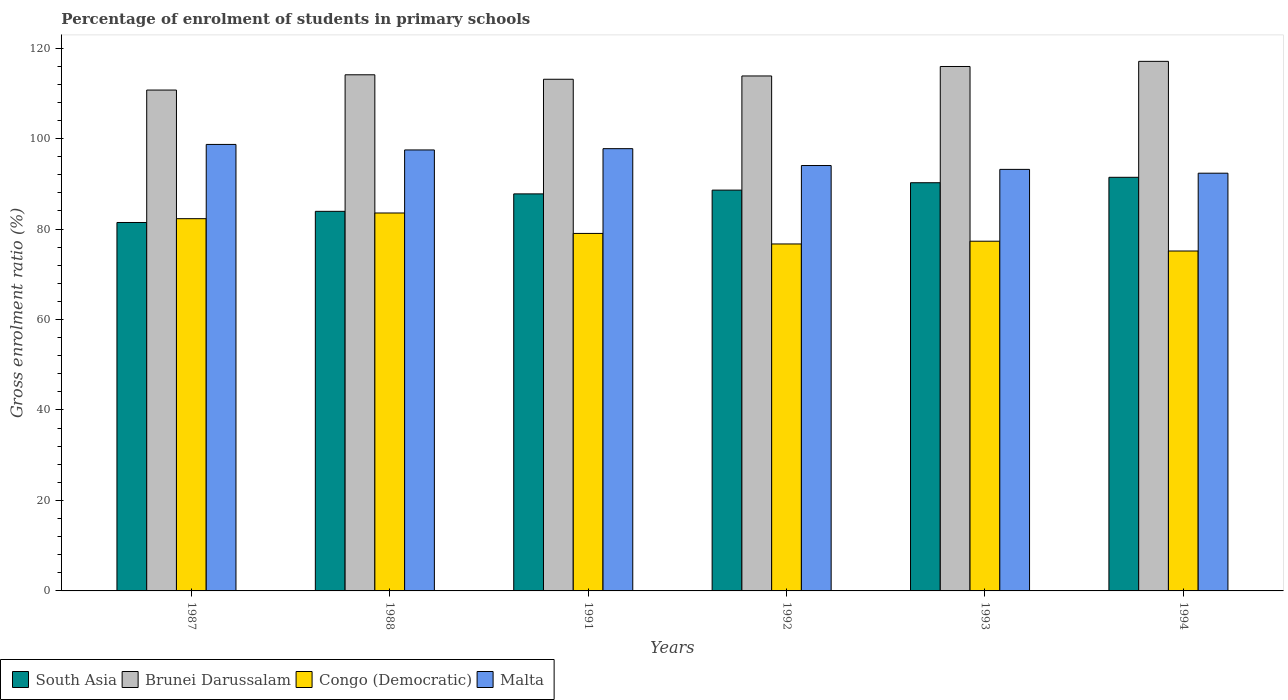Are the number of bars per tick equal to the number of legend labels?
Your answer should be very brief. Yes. Are the number of bars on each tick of the X-axis equal?
Make the answer very short. Yes. How many bars are there on the 1st tick from the right?
Provide a short and direct response. 4. In how many cases, is the number of bars for a given year not equal to the number of legend labels?
Ensure brevity in your answer.  0. What is the percentage of students enrolled in primary schools in South Asia in 1988?
Keep it short and to the point. 83.91. Across all years, what is the maximum percentage of students enrolled in primary schools in Brunei Darussalam?
Your answer should be compact. 117.07. Across all years, what is the minimum percentage of students enrolled in primary schools in South Asia?
Your answer should be compact. 81.44. In which year was the percentage of students enrolled in primary schools in Malta minimum?
Offer a very short reply. 1994. What is the total percentage of students enrolled in primary schools in Brunei Darussalam in the graph?
Your response must be concise. 684.76. What is the difference between the percentage of students enrolled in primary schools in Brunei Darussalam in 1987 and that in 1993?
Provide a succinct answer. -5.21. What is the difference between the percentage of students enrolled in primary schools in South Asia in 1987 and the percentage of students enrolled in primary schools in Congo (Democratic) in 1994?
Your response must be concise. 6.31. What is the average percentage of students enrolled in primary schools in Brunei Darussalam per year?
Your response must be concise. 114.13. In the year 1993, what is the difference between the percentage of students enrolled in primary schools in South Asia and percentage of students enrolled in primary schools in Malta?
Ensure brevity in your answer.  -2.95. In how many years, is the percentage of students enrolled in primary schools in Malta greater than 76 %?
Your response must be concise. 6. What is the ratio of the percentage of students enrolled in primary schools in Brunei Darussalam in 1992 to that in 1994?
Ensure brevity in your answer.  0.97. Is the difference between the percentage of students enrolled in primary schools in South Asia in 1992 and 1993 greater than the difference between the percentage of students enrolled in primary schools in Malta in 1992 and 1993?
Offer a terse response. No. What is the difference between the highest and the second highest percentage of students enrolled in primary schools in Congo (Democratic)?
Provide a short and direct response. 1.26. What is the difference between the highest and the lowest percentage of students enrolled in primary schools in South Asia?
Your answer should be compact. 9.99. Is the sum of the percentage of students enrolled in primary schools in Brunei Darussalam in 1988 and 1992 greater than the maximum percentage of students enrolled in primary schools in Congo (Democratic) across all years?
Provide a short and direct response. Yes. Is it the case that in every year, the sum of the percentage of students enrolled in primary schools in South Asia and percentage of students enrolled in primary schools in Congo (Democratic) is greater than the sum of percentage of students enrolled in primary schools in Malta and percentage of students enrolled in primary schools in Brunei Darussalam?
Offer a very short reply. No. What does the 2nd bar from the left in 1992 represents?
Your answer should be very brief. Brunei Darussalam. What does the 1st bar from the right in 1993 represents?
Ensure brevity in your answer.  Malta. How many years are there in the graph?
Give a very brief answer. 6. Does the graph contain any zero values?
Your answer should be very brief. No. Does the graph contain grids?
Provide a succinct answer. No. Where does the legend appear in the graph?
Your answer should be very brief. Bottom left. How many legend labels are there?
Offer a very short reply. 4. How are the legend labels stacked?
Your answer should be compact. Horizontal. What is the title of the graph?
Give a very brief answer. Percentage of enrolment of students in primary schools. Does "Pakistan" appear as one of the legend labels in the graph?
Keep it short and to the point. No. What is the label or title of the X-axis?
Keep it short and to the point. Years. What is the Gross enrolment ratio (%) in South Asia in 1987?
Provide a short and direct response. 81.44. What is the Gross enrolment ratio (%) in Brunei Darussalam in 1987?
Keep it short and to the point. 110.72. What is the Gross enrolment ratio (%) of Congo (Democratic) in 1987?
Your answer should be very brief. 82.29. What is the Gross enrolment ratio (%) of Malta in 1987?
Your answer should be compact. 98.7. What is the Gross enrolment ratio (%) of South Asia in 1988?
Offer a terse response. 83.91. What is the Gross enrolment ratio (%) of Brunei Darussalam in 1988?
Your answer should be very brief. 114.1. What is the Gross enrolment ratio (%) in Congo (Democratic) in 1988?
Your answer should be compact. 83.54. What is the Gross enrolment ratio (%) of Malta in 1988?
Your response must be concise. 97.48. What is the Gross enrolment ratio (%) in South Asia in 1991?
Your answer should be very brief. 87.77. What is the Gross enrolment ratio (%) in Brunei Darussalam in 1991?
Give a very brief answer. 113.11. What is the Gross enrolment ratio (%) of Congo (Democratic) in 1991?
Offer a terse response. 79.03. What is the Gross enrolment ratio (%) of Malta in 1991?
Ensure brevity in your answer.  97.77. What is the Gross enrolment ratio (%) in South Asia in 1992?
Offer a terse response. 88.6. What is the Gross enrolment ratio (%) of Brunei Darussalam in 1992?
Give a very brief answer. 113.84. What is the Gross enrolment ratio (%) in Congo (Democratic) in 1992?
Provide a short and direct response. 76.7. What is the Gross enrolment ratio (%) in Malta in 1992?
Your answer should be compact. 94.04. What is the Gross enrolment ratio (%) of South Asia in 1993?
Keep it short and to the point. 90.23. What is the Gross enrolment ratio (%) of Brunei Darussalam in 1993?
Your response must be concise. 115.93. What is the Gross enrolment ratio (%) of Congo (Democratic) in 1993?
Give a very brief answer. 77.31. What is the Gross enrolment ratio (%) of Malta in 1993?
Your response must be concise. 93.19. What is the Gross enrolment ratio (%) in South Asia in 1994?
Keep it short and to the point. 91.43. What is the Gross enrolment ratio (%) in Brunei Darussalam in 1994?
Make the answer very short. 117.07. What is the Gross enrolment ratio (%) in Congo (Democratic) in 1994?
Offer a very short reply. 75.14. What is the Gross enrolment ratio (%) of Malta in 1994?
Make the answer very short. 92.34. Across all years, what is the maximum Gross enrolment ratio (%) in South Asia?
Provide a succinct answer. 91.43. Across all years, what is the maximum Gross enrolment ratio (%) of Brunei Darussalam?
Provide a short and direct response. 117.07. Across all years, what is the maximum Gross enrolment ratio (%) in Congo (Democratic)?
Your response must be concise. 83.54. Across all years, what is the maximum Gross enrolment ratio (%) in Malta?
Provide a succinct answer. 98.7. Across all years, what is the minimum Gross enrolment ratio (%) in South Asia?
Offer a terse response. 81.44. Across all years, what is the minimum Gross enrolment ratio (%) of Brunei Darussalam?
Provide a short and direct response. 110.72. Across all years, what is the minimum Gross enrolment ratio (%) in Congo (Democratic)?
Provide a succinct answer. 75.14. Across all years, what is the minimum Gross enrolment ratio (%) of Malta?
Make the answer very short. 92.34. What is the total Gross enrolment ratio (%) in South Asia in the graph?
Offer a very short reply. 523.39. What is the total Gross enrolment ratio (%) in Brunei Darussalam in the graph?
Your answer should be compact. 684.76. What is the total Gross enrolment ratio (%) of Congo (Democratic) in the graph?
Give a very brief answer. 474. What is the total Gross enrolment ratio (%) in Malta in the graph?
Give a very brief answer. 573.51. What is the difference between the Gross enrolment ratio (%) of South Asia in 1987 and that in 1988?
Provide a short and direct response. -2.46. What is the difference between the Gross enrolment ratio (%) in Brunei Darussalam in 1987 and that in 1988?
Offer a very short reply. -3.38. What is the difference between the Gross enrolment ratio (%) in Congo (Democratic) in 1987 and that in 1988?
Offer a very short reply. -1.26. What is the difference between the Gross enrolment ratio (%) of Malta in 1987 and that in 1988?
Your answer should be very brief. 1.22. What is the difference between the Gross enrolment ratio (%) in South Asia in 1987 and that in 1991?
Provide a succinct answer. -6.32. What is the difference between the Gross enrolment ratio (%) of Brunei Darussalam in 1987 and that in 1991?
Offer a terse response. -2.39. What is the difference between the Gross enrolment ratio (%) in Congo (Democratic) in 1987 and that in 1991?
Ensure brevity in your answer.  3.26. What is the difference between the Gross enrolment ratio (%) of Malta in 1987 and that in 1991?
Ensure brevity in your answer.  0.93. What is the difference between the Gross enrolment ratio (%) in South Asia in 1987 and that in 1992?
Keep it short and to the point. -7.16. What is the difference between the Gross enrolment ratio (%) of Brunei Darussalam in 1987 and that in 1992?
Give a very brief answer. -3.11. What is the difference between the Gross enrolment ratio (%) in Congo (Democratic) in 1987 and that in 1992?
Provide a short and direct response. 5.59. What is the difference between the Gross enrolment ratio (%) in Malta in 1987 and that in 1992?
Your response must be concise. 4.66. What is the difference between the Gross enrolment ratio (%) in South Asia in 1987 and that in 1993?
Make the answer very short. -8.79. What is the difference between the Gross enrolment ratio (%) in Brunei Darussalam in 1987 and that in 1993?
Provide a succinct answer. -5.21. What is the difference between the Gross enrolment ratio (%) in Congo (Democratic) in 1987 and that in 1993?
Provide a short and direct response. 4.98. What is the difference between the Gross enrolment ratio (%) in Malta in 1987 and that in 1993?
Provide a short and direct response. 5.52. What is the difference between the Gross enrolment ratio (%) in South Asia in 1987 and that in 1994?
Make the answer very short. -9.99. What is the difference between the Gross enrolment ratio (%) in Brunei Darussalam in 1987 and that in 1994?
Your answer should be compact. -6.35. What is the difference between the Gross enrolment ratio (%) in Congo (Democratic) in 1987 and that in 1994?
Offer a very short reply. 7.15. What is the difference between the Gross enrolment ratio (%) of Malta in 1987 and that in 1994?
Ensure brevity in your answer.  6.36. What is the difference between the Gross enrolment ratio (%) of South Asia in 1988 and that in 1991?
Your response must be concise. -3.86. What is the difference between the Gross enrolment ratio (%) of Congo (Democratic) in 1988 and that in 1991?
Your answer should be very brief. 4.52. What is the difference between the Gross enrolment ratio (%) of Malta in 1988 and that in 1991?
Offer a very short reply. -0.29. What is the difference between the Gross enrolment ratio (%) of South Asia in 1988 and that in 1992?
Provide a succinct answer. -4.69. What is the difference between the Gross enrolment ratio (%) of Brunei Darussalam in 1988 and that in 1992?
Give a very brief answer. 0.26. What is the difference between the Gross enrolment ratio (%) in Congo (Democratic) in 1988 and that in 1992?
Keep it short and to the point. 6.84. What is the difference between the Gross enrolment ratio (%) in Malta in 1988 and that in 1992?
Your answer should be compact. 3.44. What is the difference between the Gross enrolment ratio (%) in South Asia in 1988 and that in 1993?
Your answer should be compact. -6.32. What is the difference between the Gross enrolment ratio (%) of Brunei Darussalam in 1988 and that in 1993?
Your answer should be compact. -1.83. What is the difference between the Gross enrolment ratio (%) of Congo (Democratic) in 1988 and that in 1993?
Give a very brief answer. 6.24. What is the difference between the Gross enrolment ratio (%) in Malta in 1988 and that in 1993?
Your response must be concise. 4.29. What is the difference between the Gross enrolment ratio (%) in South Asia in 1988 and that in 1994?
Ensure brevity in your answer.  -7.52. What is the difference between the Gross enrolment ratio (%) of Brunei Darussalam in 1988 and that in 1994?
Offer a very short reply. -2.97. What is the difference between the Gross enrolment ratio (%) in Congo (Democratic) in 1988 and that in 1994?
Ensure brevity in your answer.  8.4. What is the difference between the Gross enrolment ratio (%) of Malta in 1988 and that in 1994?
Offer a very short reply. 5.14. What is the difference between the Gross enrolment ratio (%) in South Asia in 1991 and that in 1992?
Provide a short and direct response. -0.83. What is the difference between the Gross enrolment ratio (%) of Brunei Darussalam in 1991 and that in 1992?
Provide a short and direct response. -0.73. What is the difference between the Gross enrolment ratio (%) of Congo (Democratic) in 1991 and that in 1992?
Keep it short and to the point. 2.33. What is the difference between the Gross enrolment ratio (%) in Malta in 1991 and that in 1992?
Ensure brevity in your answer.  3.73. What is the difference between the Gross enrolment ratio (%) in South Asia in 1991 and that in 1993?
Your response must be concise. -2.47. What is the difference between the Gross enrolment ratio (%) of Brunei Darussalam in 1991 and that in 1993?
Make the answer very short. -2.82. What is the difference between the Gross enrolment ratio (%) of Congo (Democratic) in 1991 and that in 1993?
Provide a succinct answer. 1.72. What is the difference between the Gross enrolment ratio (%) of Malta in 1991 and that in 1993?
Keep it short and to the point. 4.58. What is the difference between the Gross enrolment ratio (%) in South Asia in 1991 and that in 1994?
Your response must be concise. -3.66. What is the difference between the Gross enrolment ratio (%) of Brunei Darussalam in 1991 and that in 1994?
Your answer should be very brief. -3.96. What is the difference between the Gross enrolment ratio (%) of Congo (Democratic) in 1991 and that in 1994?
Your response must be concise. 3.89. What is the difference between the Gross enrolment ratio (%) of Malta in 1991 and that in 1994?
Offer a terse response. 5.42. What is the difference between the Gross enrolment ratio (%) in South Asia in 1992 and that in 1993?
Ensure brevity in your answer.  -1.63. What is the difference between the Gross enrolment ratio (%) in Brunei Darussalam in 1992 and that in 1993?
Give a very brief answer. -2.09. What is the difference between the Gross enrolment ratio (%) of Congo (Democratic) in 1992 and that in 1993?
Offer a terse response. -0.6. What is the difference between the Gross enrolment ratio (%) of Malta in 1992 and that in 1993?
Your response must be concise. 0.85. What is the difference between the Gross enrolment ratio (%) of South Asia in 1992 and that in 1994?
Offer a terse response. -2.83. What is the difference between the Gross enrolment ratio (%) of Brunei Darussalam in 1992 and that in 1994?
Your response must be concise. -3.23. What is the difference between the Gross enrolment ratio (%) of Congo (Democratic) in 1992 and that in 1994?
Offer a very short reply. 1.56. What is the difference between the Gross enrolment ratio (%) of Malta in 1992 and that in 1994?
Your answer should be very brief. 1.7. What is the difference between the Gross enrolment ratio (%) of South Asia in 1993 and that in 1994?
Make the answer very short. -1.2. What is the difference between the Gross enrolment ratio (%) in Brunei Darussalam in 1993 and that in 1994?
Your answer should be very brief. -1.14. What is the difference between the Gross enrolment ratio (%) in Congo (Democratic) in 1993 and that in 1994?
Your answer should be compact. 2.17. What is the difference between the Gross enrolment ratio (%) in Malta in 1993 and that in 1994?
Provide a short and direct response. 0.84. What is the difference between the Gross enrolment ratio (%) in South Asia in 1987 and the Gross enrolment ratio (%) in Brunei Darussalam in 1988?
Provide a short and direct response. -32.65. What is the difference between the Gross enrolment ratio (%) in South Asia in 1987 and the Gross enrolment ratio (%) in Congo (Democratic) in 1988?
Provide a succinct answer. -2.1. What is the difference between the Gross enrolment ratio (%) of South Asia in 1987 and the Gross enrolment ratio (%) of Malta in 1988?
Make the answer very short. -16.04. What is the difference between the Gross enrolment ratio (%) in Brunei Darussalam in 1987 and the Gross enrolment ratio (%) in Congo (Democratic) in 1988?
Give a very brief answer. 27.18. What is the difference between the Gross enrolment ratio (%) in Brunei Darussalam in 1987 and the Gross enrolment ratio (%) in Malta in 1988?
Offer a terse response. 13.24. What is the difference between the Gross enrolment ratio (%) in Congo (Democratic) in 1987 and the Gross enrolment ratio (%) in Malta in 1988?
Ensure brevity in your answer.  -15.19. What is the difference between the Gross enrolment ratio (%) of South Asia in 1987 and the Gross enrolment ratio (%) of Brunei Darussalam in 1991?
Your answer should be very brief. -31.66. What is the difference between the Gross enrolment ratio (%) of South Asia in 1987 and the Gross enrolment ratio (%) of Congo (Democratic) in 1991?
Make the answer very short. 2.42. What is the difference between the Gross enrolment ratio (%) in South Asia in 1987 and the Gross enrolment ratio (%) in Malta in 1991?
Provide a succinct answer. -16.32. What is the difference between the Gross enrolment ratio (%) in Brunei Darussalam in 1987 and the Gross enrolment ratio (%) in Congo (Democratic) in 1991?
Your answer should be very brief. 31.69. What is the difference between the Gross enrolment ratio (%) of Brunei Darussalam in 1987 and the Gross enrolment ratio (%) of Malta in 1991?
Keep it short and to the point. 12.95. What is the difference between the Gross enrolment ratio (%) of Congo (Democratic) in 1987 and the Gross enrolment ratio (%) of Malta in 1991?
Offer a very short reply. -15.48. What is the difference between the Gross enrolment ratio (%) in South Asia in 1987 and the Gross enrolment ratio (%) in Brunei Darussalam in 1992?
Provide a short and direct response. -32.39. What is the difference between the Gross enrolment ratio (%) of South Asia in 1987 and the Gross enrolment ratio (%) of Congo (Democratic) in 1992?
Ensure brevity in your answer.  4.74. What is the difference between the Gross enrolment ratio (%) in South Asia in 1987 and the Gross enrolment ratio (%) in Malta in 1992?
Your response must be concise. -12.59. What is the difference between the Gross enrolment ratio (%) in Brunei Darussalam in 1987 and the Gross enrolment ratio (%) in Congo (Democratic) in 1992?
Your answer should be very brief. 34.02. What is the difference between the Gross enrolment ratio (%) in Brunei Darussalam in 1987 and the Gross enrolment ratio (%) in Malta in 1992?
Provide a short and direct response. 16.68. What is the difference between the Gross enrolment ratio (%) of Congo (Democratic) in 1987 and the Gross enrolment ratio (%) of Malta in 1992?
Provide a succinct answer. -11.75. What is the difference between the Gross enrolment ratio (%) of South Asia in 1987 and the Gross enrolment ratio (%) of Brunei Darussalam in 1993?
Offer a terse response. -34.48. What is the difference between the Gross enrolment ratio (%) of South Asia in 1987 and the Gross enrolment ratio (%) of Congo (Democratic) in 1993?
Keep it short and to the point. 4.14. What is the difference between the Gross enrolment ratio (%) of South Asia in 1987 and the Gross enrolment ratio (%) of Malta in 1993?
Your answer should be very brief. -11.74. What is the difference between the Gross enrolment ratio (%) of Brunei Darussalam in 1987 and the Gross enrolment ratio (%) of Congo (Democratic) in 1993?
Your answer should be compact. 33.42. What is the difference between the Gross enrolment ratio (%) of Brunei Darussalam in 1987 and the Gross enrolment ratio (%) of Malta in 1993?
Keep it short and to the point. 17.53. What is the difference between the Gross enrolment ratio (%) of Congo (Democratic) in 1987 and the Gross enrolment ratio (%) of Malta in 1993?
Give a very brief answer. -10.9. What is the difference between the Gross enrolment ratio (%) in South Asia in 1987 and the Gross enrolment ratio (%) in Brunei Darussalam in 1994?
Ensure brevity in your answer.  -35.62. What is the difference between the Gross enrolment ratio (%) in South Asia in 1987 and the Gross enrolment ratio (%) in Congo (Democratic) in 1994?
Keep it short and to the point. 6.31. What is the difference between the Gross enrolment ratio (%) in South Asia in 1987 and the Gross enrolment ratio (%) in Malta in 1994?
Provide a short and direct response. -10.9. What is the difference between the Gross enrolment ratio (%) of Brunei Darussalam in 1987 and the Gross enrolment ratio (%) of Congo (Democratic) in 1994?
Your response must be concise. 35.58. What is the difference between the Gross enrolment ratio (%) of Brunei Darussalam in 1987 and the Gross enrolment ratio (%) of Malta in 1994?
Offer a terse response. 18.38. What is the difference between the Gross enrolment ratio (%) in Congo (Democratic) in 1987 and the Gross enrolment ratio (%) in Malta in 1994?
Your response must be concise. -10.06. What is the difference between the Gross enrolment ratio (%) of South Asia in 1988 and the Gross enrolment ratio (%) of Brunei Darussalam in 1991?
Your answer should be very brief. -29.2. What is the difference between the Gross enrolment ratio (%) in South Asia in 1988 and the Gross enrolment ratio (%) in Congo (Democratic) in 1991?
Give a very brief answer. 4.88. What is the difference between the Gross enrolment ratio (%) of South Asia in 1988 and the Gross enrolment ratio (%) of Malta in 1991?
Keep it short and to the point. -13.86. What is the difference between the Gross enrolment ratio (%) in Brunei Darussalam in 1988 and the Gross enrolment ratio (%) in Congo (Democratic) in 1991?
Offer a terse response. 35.07. What is the difference between the Gross enrolment ratio (%) of Brunei Darussalam in 1988 and the Gross enrolment ratio (%) of Malta in 1991?
Your answer should be compact. 16.33. What is the difference between the Gross enrolment ratio (%) in Congo (Democratic) in 1988 and the Gross enrolment ratio (%) in Malta in 1991?
Your answer should be very brief. -14.22. What is the difference between the Gross enrolment ratio (%) in South Asia in 1988 and the Gross enrolment ratio (%) in Brunei Darussalam in 1992?
Provide a succinct answer. -29.93. What is the difference between the Gross enrolment ratio (%) in South Asia in 1988 and the Gross enrolment ratio (%) in Congo (Democratic) in 1992?
Keep it short and to the point. 7.21. What is the difference between the Gross enrolment ratio (%) in South Asia in 1988 and the Gross enrolment ratio (%) in Malta in 1992?
Make the answer very short. -10.13. What is the difference between the Gross enrolment ratio (%) in Brunei Darussalam in 1988 and the Gross enrolment ratio (%) in Congo (Democratic) in 1992?
Offer a terse response. 37.4. What is the difference between the Gross enrolment ratio (%) of Brunei Darussalam in 1988 and the Gross enrolment ratio (%) of Malta in 1992?
Your answer should be very brief. 20.06. What is the difference between the Gross enrolment ratio (%) in Congo (Democratic) in 1988 and the Gross enrolment ratio (%) in Malta in 1992?
Offer a very short reply. -10.49. What is the difference between the Gross enrolment ratio (%) of South Asia in 1988 and the Gross enrolment ratio (%) of Brunei Darussalam in 1993?
Ensure brevity in your answer.  -32.02. What is the difference between the Gross enrolment ratio (%) of South Asia in 1988 and the Gross enrolment ratio (%) of Congo (Democratic) in 1993?
Your response must be concise. 6.6. What is the difference between the Gross enrolment ratio (%) in South Asia in 1988 and the Gross enrolment ratio (%) in Malta in 1993?
Offer a terse response. -9.28. What is the difference between the Gross enrolment ratio (%) of Brunei Darussalam in 1988 and the Gross enrolment ratio (%) of Congo (Democratic) in 1993?
Make the answer very short. 36.79. What is the difference between the Gross enrolment ratio (%) in Brunei Darussalam in 1988 and the Gross enrolment ratio (%) in Malta in 1993?
Keep it short and to the point. 20.91. What is the difference between the Gross enrolment ratio (%) in Congo (Democratic) in 1988 and the Gross enrolment ratio (%) in Malta in 1993?
Your answer should be very brief. -9.64. What is the difference between the Gross enrolment ratio (%) in South Asia in 1988 and the Gross enrolment ratio (%) in Brunei Darussalam in 1994?
Your answer should be very brief. -33.16. What is the difference between the Gross enrolment ratio (%) of South Asia in 1988 and the Gross enrolment ratio (%) of Congo (Democratic) in 1994?
Ensure brevity in your answer.  8.77. What is the difference between the Gross enrolment ratio (%) of South Asia in 1988 and the Gross enrolment ratio (%) of Malta in 1994?
Make the answer very short. -8.43. What is the difference between the Gross enrolment ratio (%) of Brunei Darussalam in 1988 and the Gross enrolment ratio (%) of Congo (Democratic) in 1994?
Keep it short and to the point. 38.96. What is the difference between the Gross enrolment ratio (%) of Brunei Darussalam in 1988 and the Gross enrolment ratio (%) of Malta in 1994?
Keep it short and to the point. 21.75. What is the difference between the Gross enrolment ratio (%) in Congo (Democratic) in 1988 and the Gross enrolment ratio (%) in Malta in 1994?
Give a very brief answer. -8.8. What is the difference between the Gross enrolment ratio (%) of South Asia in 1991 and the Gross enrolment ratio (%) of Brunei Darussalam in 1992?
Your answer should be compact. -26.07. What is the difference between the Gross enrolment ratio (%) of South Asia in 1991 and the Gross enrolment ratio (%) of Congo (Democratic) in 1992?
Provide a short and direct response. 11.07. What is the difference between the Gross enrolment ratio (%) of South Asia in 1991 and the Gross enrolment ratio (%) of Malta in 1992?
Provide a short and direct response. -6.27. What is the difference between the Gross enrolment ratio (%) in Brunei Darussalam in 1991 and the Gross enrolment ratio (%) in Congo (Democratic) in 1992?
Make the answer very short. 36.41. What is the difference between the Gross enrolment ratio (%) in Brunei Darussalam in 1991 and the Gross enrolment ratio (%) in Malta in 1992?
Make the answer very short. 19.07. What is the difference between the Gross enrolment ratio (%) of Congo (Democratic) in 1991 and the Gross enrolment ratio (%) of Malta in 1992?
Provide a short and direct response. -15.01. What is the difference between the Gross enrolment ratio (%) in South Asia in 1991 and the Gross enrolment ratio (%) in Brunei Darussalam in 1993?
Your answer should be compact. -28.16. What is the difference between the Gross enrolment ratio (%) of South Asia in 1991 and the Gross enrolment ratio (%) of Congo (Democratic) in 1993?
Make the answer very short. 10.46. What is the difference between the Gross enrolment ratio (%) of South Asia in 1991 and the Gross enrolment ratio (%) of Malta in 1993?
Give a very brief answer. -5.42. What is the difference between the Gross enrolment ratio (%) in Brunei Darussalam in 1991 and the Gross enrolment ratio (%) in Congo (Democratic) in 1993?
Give a very brief answer. 35.8. What is the difference between the Gross enrolment ratio (%) in Brunei Darussalam in 1991 and the Gross enrolment ratio (%) in Malta in 1993?
Your answer should be very brief. 19.92. What is the difference between the Gross enrolment ratio (%) in Congo (Democratic) in 1991 and the Gross enrolment ratio (%) in Malta in 1993?
Keep it short and to the point. -14.16. What is the difference between the Gross enrolment ratio (%) in South Asia in 1991 and the Gross enrolment ratio (%) in Brunei Darussalam in 1994?
Your answer should be compact. -29.3. What is the difference between the Gross enrolment ratio (%) in South Asia in 1991 and the Gross enrolment ratio (%) in Congo (Democratic) in 1994?
Keep it short and to the point. 12.63. What is the difference between the Gross enrolment ratio (%) of South Asia in 1991 and the Gross enrolment ratio (%) of Malta in 1994?
Keep it short and to the point. -4.57. What is the difference between the Gross enrolment ratio (%) in Brunei Darussalam in 1991 and the Gross enrolment ratio (%) in Congo (Democratic) in 1994?
Your response must be concise. 37.97. What is the difference between the Gross enrolment ratio (%) of Brunei Darussalam in 1991 and the Gross enrolment ratio (%) of Malta in 1994?
Your answer should be very brief. 20.77. What is the difference between the Gross enrolment ratio (%) in Congo (Democratic) in 1991 and the Gross enrolment ratio (%) in Malta in 1994?
Your response must be concise. -13.31. What is the difference between the Gross enrolment ratio (%) in South Asia in 1992 and the Gross enrolment ratio (%) in Brunei Darussalam in 1993?
Ensure brevity in your answer.  -27.33. What is the difference between the Gross enrolment ratio (%) of South Asia in 1992 and the Gross enrolment ratio (%) of Congo (Democratic) in 1993?
Give a very brief answer. 11.3. What is the difference between the Gross enrolment ratio (%) in South Asia in 1992 and the Gross enrolment ratio (%) in Malta in 1993?
Offer a terse response. -4.59. What is the difference between the Gross enrolment ratio (%) in Brunei Darussalam in 1992 and the Gross enrolment ratio (%) in Congo (Democratic) in 1993?
Make the answer very short. 36.53. What is the difference between the Gross enrolment ratio (%) in Brunei Darussalam in 1992 and the Gross enrolment ratio (%) in Malta in 1993?
Make the answer very short. 20.65. What is the difference between the Gross enrolment ratio (%) in Congo (Democratic) in 1992 and the Gross enrolment ratio (%) in Malta in 1993?
Provide a short and direct response. -16.49. What is the difference between the Gross enrolment ratio (%) in South Asia in 1992 and the Gross enrolment ratio (%) in Brunei Darussalam in 1994?
Keep it short and to the point. -28.47. What is the difference between the Gross enrolment ratio (%) of South Asia in 1992 and the Gross enrolment ratio (%) of Congo (Democratic) in 1994?
Your answer should be compact. 13.46. What is the difference between the Gross enrolment ratio (%) in South Asia in 1992 and the Gross enrolment ratio (%) in Malta in 1994?
Offer a very short reply. -3.74. What is the difference between the Gross enrolment ratio (%) in Brunei Darussalam in 1992 and the Gross enrolment ratio (%) in Congo (Democratic) in 1994?
Give a very brief answer. 38.7. What is the difference between the Gross enrolment ratio (%) of Brunei Darussalam in 1992 and the Gross enrolment ratio (%) of Malta in 1994?
Your response must be concise. 21.49. What is the difference between the Gross enrolment ratio (%) in Congo (Democratic) in 1992 and the Gross enrolment ratio (%) in Malta in 1994?
Your answer should be very brief. -15.64. What is the difference between the Gross enrolment ratio (%) in South Asia in 1993 and the Gross enrolment ratio (%) in Brunei Darussalam in 1994?
Give a very brief answer. -26.83. What is the difference between the Gross enrolment ratio (%) of South Asia in 1993 and the Gross enrolment ratio (%) of Congo (Democratic) in 1994?
Give a very brief answer. 15.1. What is the difference between the Gross enrolment ratio (%) in South Asia in 1993 and the Gross enrolment ratio (%) in Malta in 1994?
Your response must be concise. -2.11. What is the difference between the Gross enrolment ratio (%) of Brunei Darussalam in 1993 and the Gross enrolment ratio (%) of Congo (Democratic) in 1994?
Offer a very short reply. 40.79. What is the difference between the Gross enrolment ratio (%) of Brunei Darussalam in 1993 and the Gross enrolment ratio (%) of Malta in 1994?
Keep it short and to the point. 23.59. What is the difference between the Gross enrolment ratio (%) in Congo (Democratic) in 1993 and the Gross enrolment ratio (%) in Malta in 1994?
Keep it short and to the point. -15.04. What is the average Gross enrolment ratio (%) of South Asia per year?
Offer a very short reply. 87.23. What is the average Gross enrolment ratio (%) in Brunei Darussalam per year?
Provide a succinct answer. 114.13. What is the average Gross enrolment ratio (%) of Congo (Democratic) per year?
Give a very brief answer. 79. What is the average Gross enrolment ratio (%) in Malta per year?
Your answer should be compact. 95.59. In the year 1987, what is the difference between the Gross enrolment ratio (%) in South Asia and Gross enrolment ratio (%) in Brunei Darussalam?
Ensure brevity in your answer.  -29.28. In the year 1987, what is the difference between the Gross enrolment ratio (%) in South Asia and Gross enrolment ratio (%) in Congo (Democratic)?
Offer a terse response. -0.84. In the year 1987, what is the difference between the Gross enrolment ratio (%) in South Asia and Gross enrolment ratio (%) in Malta?
Keep it short and to the point. -17.26. In the year 1987, what is the difference between the Gross enrolment ratio (%) in Brunei Darussalam and Gross enrolment ratio (%) in Congo (Democratic)?
Make the answer very short. 28.43. In the year 1987, what is the difference between the Gross enrolment ratio (%) of Brunei Darussalam and Gross enrolment ratio (%) of Malta?
Offer a terse response. 12.02. In the year 1987, what is the difference between the Gross enrolment ratio (%) in Congo (Democratic) and Gross enrolment ratio (%) in Malta?
Your response must be concise. -16.41. In the year 1988, what is the difference between the Gross enrolment ratio (%) in South Asia and Gross enrolment ratio (%) in Brunei Darussalam?
Your response must be concise. -30.19. In the year 1988, what is the difference between the Gross enrolment ratio (%) in South Asia and Gross enrolment ratio (%) in Congo (Democratic)?
Offer a very short reply. 0.37. In the year 1988, what is the difference between the Gross enrolment ratio (%) of South Asia and Gross enrolment ratio (%) of Malta?
Make the answer very short. -13.57. In the year 1988, what is the difference between the Gross enrolment ratio (%) of Brunei Darussalam and Gross enrolment ratio (%) of Congo (Democratic)?
Your response must be concise. 30.55. In the year 1988, what is the difference between the Gross enrolment ratio (%) of Brunei Darussalam and Gross enrolment ratio (%) of Malta?
Ensure brevity in your answer.  16.62. In the year 1988, what is the difference between the Gross enrolment ratio (%) in Congo (Democratic) and Gross enrolment ratio (%) in Malta?
Your response must be concise. -13.94. In the year 1991, what is the difference between the Gross enrolment ratio (%) in South Asia and Gross enrolment ratio (%) in Brunei Darussalam?
Provide a short and direct response. -25.34. In the year 1991, what is the difference between the Gross enrolment ratio (%) in South Asia and Gross enrolment ratio (%) in Congo (Democratic)?
Keep it short and to the point. 8.74. In the year 1991, what is the difference between the Gross enrolment ratio (%) in South Asia and Gross enrolment ratio (%) in Malta?
Your answer should be compact. -10. In the year 1991, what is the difference between the Gross enrolment ratio (%) of Brunei Darussalam and Gross enrolment ratio (%) of Congo (Democratic)?
Give a very brief answer. 34.08. In the year 1991, what is the difference between the Gross enrolment ratio (%) of Brunei Darussalam and Gross enrolment ratio (%) of Malta?
Provide a short and direct response. 15.34. In the year 1991, what is the difference between the Gross enrolment ratio (%) of Congo (Democratic) and Gross enrolment ratio (%) of Malta?
Offer a terse response. -18.74. In the year 1992, what is the difference between the Gross enrolment ratio (%) in South Asia and Gross enrolment ratio (%) in Brunei Darussalam?
Offer a very short reply. -25.23. In the year 1992, what is the difference between the Gross enrolment ratio (%) of South Asia and Gross enrolment ratio (%) of Congo (Democratic)?
Offer a very short reply. 11.9. In the year 1992, what is the difference between the Gross enrolment ratio (%) of South Asia and Gross enrolment ratio (%) of Malta?
Your answer should be compact. -5.44. In the year 1992, what is the difference between the Gross enrolment ratio (%) in Brunei Darussalam and Gross enrolment ratio (%) in Congo (Democratic)?
Provide a succinct answer. 37.14. In the year 1992, what is the difference between the Gross enrolment ratio (%) in Brunei Darussalam and Gross enrolment ratio (%) in Malta?
Give a very brief answer. 19.8. In the year 1992, what is the difference between the Gross enrolment ratio (%) in Congo (Democratic) and Gross enrolment ratio (%) in Malta?
Your response must be concise. -17.34. In the year 1993, what is the difference between the Gross enrolment ratio (%) of South Asia and Gross enrolment ratio (%) of Brunei Darussalam?
Your answer should be very brief. -25.69. In the year 1993, what is the difference between the Gross enrolment ratio (%) in South Asia and Gross enrolment ratio (%) in Congo (Democratic)?
Offer a terse response. 12.93. In the year 1993, what is the difference between the Gross enrolment ratio (%) of South Asia and Gross enrolment ratio (%) of Malta?
Your answer should be very brief. -2.95. In the year 1993, what is the difference between the Gross enrolment ratio (%) of Brunei Darussalam and Gross enrolment ratio (%) of Congo (Democratic)?
Your answer should be very brief. 38.62. In the year 1993, what is the difference between the Gross enrolment ratio (%) of Brunei Darussalam and Gross enrolment ratio (%) of Malta?
Provide a short and direct response. 22.74. In the year 1993, what is the difference between the Gross enrolment ratio (%) in Congo (Democratic) and Gross enrolment ratio (%) in Malta?
Your answer should be compact. -15.88. In the year 1994, what is the difference between the Gross enrolment ratio (%) in South Asia and Gross enrolment ratio (%) in Brunei Darussalam?
Ensure brevity in your answer.  -25.63. In the year 1994, what is the difference between the Gross enrolment ratio (%) of South Asia and Gross enrolment ratio (%) of Congo (Democratic)?
Give a very brief answer. 16.29. In the year 1994, what is the difference between the Gross enrolment ratio (%) in South Asia and Gross enrolment ratio (%) in Malta?
Your response must be concise. -0.91. In the year 1994, what is the difference between the Gross enrolment ratio (%) in Brunei Darussalam and Gross enrolment ratio (%) in Congo (Democratic)?
Keep it short and to the point. 41.93. In the year 1994, what is the difference between the Gross enrolment ratio (%) of Brunei Darussalam and Gross enrolment ratio (%) of Malta?
Make the answer very short. 24.72. In the year 1994, what is the difference between the Gross enrolment ratio (%) of Congo (Democratic) and Gross enrolment ratio (%) of Malta?
Offer a very short reply. -17.2. What is the ratio of the Gross enrolment ratio (%) in South Asia in 1987 to that in 1988?
Your response must be concise. 0.97. What is the ratio of the Gross enrolment ratio (%) in Brunei Darussalam in 1987 to that in 1988?
Your answer should be compact. 0.97. What is the ratio of the Gross enrolment ratio (%) of Congo (Democratic) in 1987 to that in 1988?
Your response must be concise. 0.98. What is the ratio of the Gross enrolment ratio (%) in Malta in 1987 to that in 1988?
Make the answer very short. 1.01. What is the ratio of the Gross enrolment ratio (%) in South Asia in 1987 to that in 1991?
Provide a succinct answer. 0.93. What is the ratio of the Gross enrolment ratio (%) of Brunei Darussalam in 1987 to that in 1991?
Give a very brief answer. 0.98. What is the ratio of the Gross enrolment ratio (%) in Congo (Democratic) in 1987 to that in 1991?
Ensure brevity in your answer.  1.04. What is the ratio of the Gross enrolment ratio (%) of Malta in 1987 to that in 1991?
Keep it short and to the point. 1.01. What is the ratio of the Gross enrolment ratio (%) in South Asia in 1987 to that in 1992?
Keep it short and to the point. 0.92. What is the ratio of the Gross enrolment ratio (%) of Brunei Darussalam in 1987 to that in 1992?
Offer a very short reply. 0.97. What is the ratio of the Gross enrolment ratio (%) in Congo (Democratic) in 1987 to that in 1992?
Give a very brief answer. 1.07. What is the ratio of the Gross enrolment ratio (%) of Malta in 1987 to that in 1992?
Offer a very short reply. 1.05. What is the ratio of the Gross enrolment ratio (%) in South Asia in 1987 to that in 1993?
Offer a very short reply. 0.9. What is the ratio of the Gross enrolment ratio (%) in Brunei Darussalam in 1987 to that in 1993?
Your response must be concise. 0.96. What is the ratio of the Gross enrolment ratio (%) of Congo (Democratic) in 1987 to that in 1993?
Ensure brevity in your answer.  1.06. What is the ratio of the Gross enrolment ratio (%) of Malta in 1987 to that in 1993?
Your response must be concise. 1.06. What is the ratio of the Gross enrolment ratio (%) in South Asia in 1987 to that in 1994?
Offer a terse response. 0.89. What is the ratio of the Gross enrolment ratio (%) of Brunei Darussalam in 1987 to that in 1994?
Ensure brevity in your answer.  0.95. What is the ratio of the Gross enrolment ratio (%) in Congo (Democratic) in 1987 to that in 1994?
Offer a very short reply. 1.1. What is the ratio of the Gross enrolment ratio (%) in Malta in 1987 to that in 1994?
Ensure brevity in your answer.  1.07. What is the ratio of the Gross enrolment ratio (%) in South Asia in 1988 to that in 1991?
Make the answer very short. 0.96. What is the ratio of the Gross enrolment ratio (%) in Brunei Darussalam in 1988 to that in 1991?
Offer a very short reply. 1.01. What is the ratio of the Gross enrolment ratio (%) in Congo (Democratic) in 1988 to that in 1991?
Offer a terse response. 1.06. What is the ratio of the Gross enrolment ratio (%) of South Asia in 1988 to that in 1992?
Ensure brevity in your answer.  0.95. What is the ratio of the Gross enrolment ratio (%) of Brunei Darussalam in 1988 to that in 1992?
Keep it short and to the point. 1. What is the ratio of the Gross enrolment ratio (%) of Congo (Democratic) in 1988 to that in 1992?
Provide a succinct answer. 1.09. What is the ratio of the Gross enrolment ratio (%) in Malta in 1988 to that in 1992?
Provide a succinct answer. 1.04. What is the ratio of the Gross enrolment ratio (%) in South Asia in 1988 to that in 1993?
Your answer should be very brief. 0.93. What is the ratio of the Gross enrolment ratio (%) of Brunei Darussalam in 1988 to that in 1993?
Give a very brief answer. 0.98. What is the ratio of the Gross enrolment ratio (%) in Congo (Democratic) in 1988 to that in 1993?
Your answer should be very brief. 1.08. What is the ratio of the Gross enrolment ratio (%) of Malta in 1988 to that in 1993?
Ensure brevity in your answer.  1.05. What is the ratio of the Gross enrolment ratio (%) in South Asia in 1988 to that in 1994?
Your answer should be very brief. 0.92. What is the ratio of the Gross enrolment ratio (%) of Brunei Darussalam in 1988 to that in 1994?
Your answer should be very brief. 0.97. What is the ratio of the Gross enrolment ratio (%) in Congo (Democratic) in 1988 to that in 1994?
Your answer should be very brief. 1.11. What is the ratio of the Gross enrolment ratio (%) in Malta in 1988 to that in 1994?
Your answer should be compact. 1.06. What is the ratio of the Gross enrolment ratio (%) in South Asia in 1991 to that in 1992?
Make the answer very short. 0.99. What is the ratio of the Gross enrolment ratio (%) of Brunei Darussalam in 1991 to that in 1992?
Provide a short and direct response. 0.99. What is the ratio of the Gross enrolment ratio (%) of Congo (Democratic) in 1991 to that in 1992?
Ensure brevity in your answer.  1.03. What is the ratio of the Gross enrolment ratio (%) of Malta in 1991 to that in 1992?
Offer a terse response. 1.04. What is the ratio of the Gross enrolment ratio (%) of South Asia in 1991 to that in 1993?
Offer a terse response. 0.97. What is the ratio of the Gross enrolment ratio (%) of Brunei Darussalam in 1991 to that in 1993?
Offer a terse response. 0.98. What is the ratio of the Gross enrolment ratio (%) in Congo (Democratic) in 1991 to that in 1993?
Ensure brevity in your answer.  1.02. What is the ratio of the Gross enrolment ratio (%) of Malta in 1991 to that in 1993?
Make the answer very short. 1.05. What is the ratio of the Gross enrolment ratio (%) of South Asia in 1991 to that in 1994?
Your response must be concise. 0.96. What is the ratio of the Gross enrolment ratio (%) of Brunei Darussalam in 1991 to that in 1994?
Keep it short and to the point. 0.97. What is the ratio of the Gross enrolment ratio (%) in Congo (Democratic) in 1991 to that in 1994?
Your response must be concise. 1.05. What is the ratio of the Gross enrolment ratio (%) in Malta in 1991 to that in 1994?
Your answer should be compact. 1.06. What is the ratio of the Gross enrolment ratio (%) of South Asia in 1992 to that in 1993?
Offer a very short reply. 0.98. What is the ratio of the Gross enrolment ratio (%) of Brunei Darussalam in 1992 to that in 1993?
Give a very brief answer. 0.98. What is the ratio of the Gross enrolment ratio (%) of Congo (Democratic) in 1992 to that in 1993?
Your answer should be compact. 0.99. What is the ratio of the Gross enrolment ratio (%) of Malta in 1992 to that in 1993?
Provide a short and direct response. 1.01. What is the ratio of the Gross enrolment ratio (%) in Brunei Darussalam in 1992 to that in 1994?
Provide a succinct answer. 0.97. What is the ratio of the Gross enrolment ratio (%) in Congo (Democratic) in 1992 to that in 1994?
Make the answer very short. 1.02. What is the ratio of the Gross enrolment ratio (%) of Malta in 1992 to that in 1994?
Give a very brief answer. 1.02. What is the ratio of the Gross enrolment ratio (%) of South Asia in 1993 to that in 1994?
Offer a terse response. 0.99. What is the ratio of the Gross enrolment ratio (%) in Brunei Darussalam in 1993 to that in 1994?
Give a very brief answer. 0.99. What is the ratio of the Gross enrolment ratio (%) in Congo (Democratic) in 1993 to that in 1994?
Provide a succinct answer. 1.03. What is the ratio of the Gross enrolment ratio (%) of Malta in 1993 to that in 1994?
Provide a short and direct response. 1.01. What is the difference between the highest and the second highest Gross enrolment ratio (%) in South Asia?
Your answer should be compact. 1.2. What is the difference between the highest and the second highest Gross enrolment ratio (%) in Brunei Darussalam?
Provide a succinct answer. 1.14. What is the difference between the highest and the second highest Gross enrolment ratio (%) in Congo (Democratic)?
Your response must be concise. 1.26. What is the difference between the highest and the second highest Gross enrolment ratio (%) of Malta?
Provide a succinct answer. 0.93. What is the difference between the highest and the lowest Gross enrolment ratio (%) in South Asia?
Offer a very short reply. 9.99. What is the difference between the highest and the lowest Gross enrolment ratio (%) in Brunei Darussalam?
Your answer should be very brief. 6.35. What is the difference between the highest and the lowest Gross enrolment ratio (%) in Congo (Democratic)?
Your response must be concise. 8.4. What is the difference between the highest and the lowest Gross enrolment ratio (%) of Malta?
Your response must be concise. 6.36. 